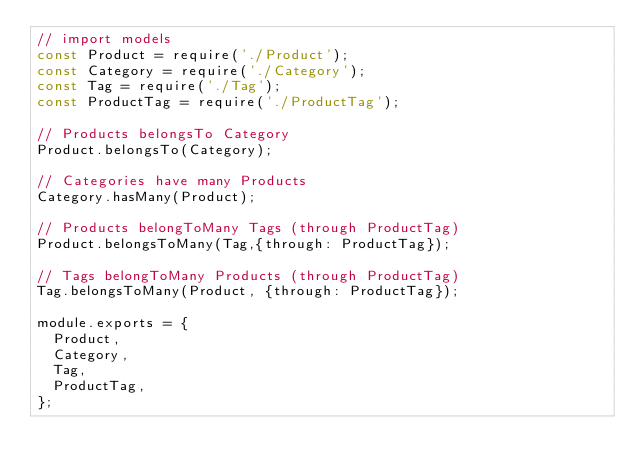Convert code to text. <code><loc_0><loc_0><loc_500><loc_500><_JavaScript_>// import models
const Product = require('./Product');
const Category = require('./Category');
const Tag = require('./Tag');
const ProductTag = require('./ProductTag');

// Products belongsTo Category
Product.belongsTo(Category);

// Categories have many Products
Category.hasMany(Product);

// Products belongToMany Tags (through ProductTag)
Product.belongsToMany(Tag,{through: ProductTag});

// Tags belongToMany Products (through ProductTag)
Tag.belongsToMany(Product, {through: ProductTag});

module.exports = {
  Product,
  Category,
  Tag,
  ProductTag,
};
</code> 